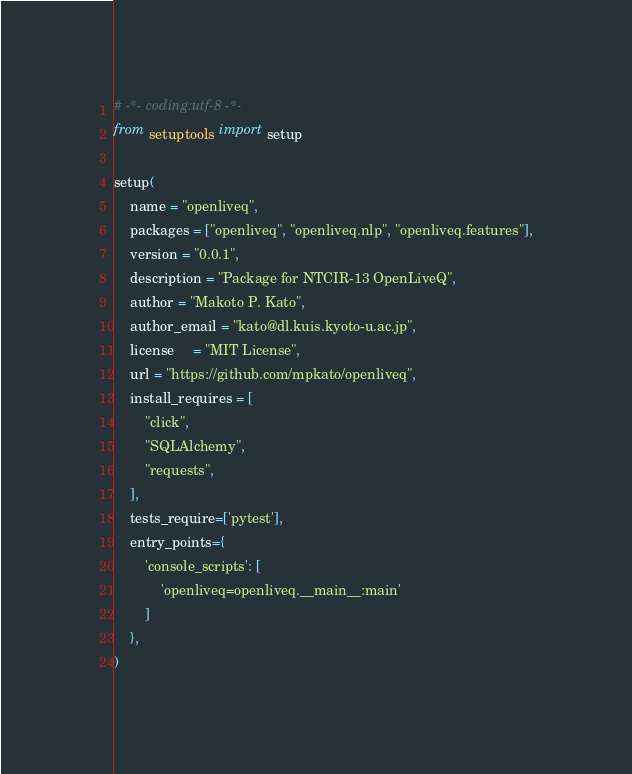<code> <loc_0><loc_0><loc_500><loc_500><_Python_># -*- coding:utf-8 -*-
from setuptools import setup

setup(
    name = "openliveq",
    packages = ["openliveq", "openliveq.nlp", "openliveq.features"],
    version = "0.0.1",
    description = "Package for NTCIR-13 OpenLiveQ",
    author = "Makoto P. Kato",
    author_email = "kato@dl.kuis.kyoto-u.ac.jp",
    license     = "MIT License",
    url = "https://github.com/mpkato/openliveq",
    install_requires = [
        "click",
        "SQLAlchemy",
        "requests",
    ],
    tests_require=['pytest'],
    entry_points={
        'console_scripts': [
            'openliveq=openliveq.__main__:main'
        ]
    },
)
</code> 